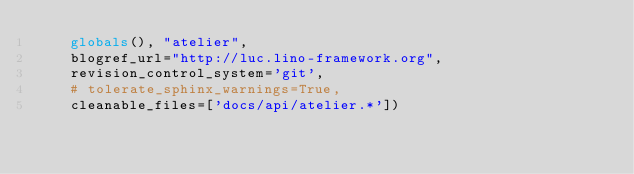Convert code to text. <code><loc_0><loc_0><loc_500><loc_500><_Python_>    globals(), "atelier",
    blogref_url="http://luc.lino-framework.org",
    revision_control_system='git',
    # tolerate_sphinx_warnings=True,
    cleanable_files=['docs/api/atelier.*'])
</code> 